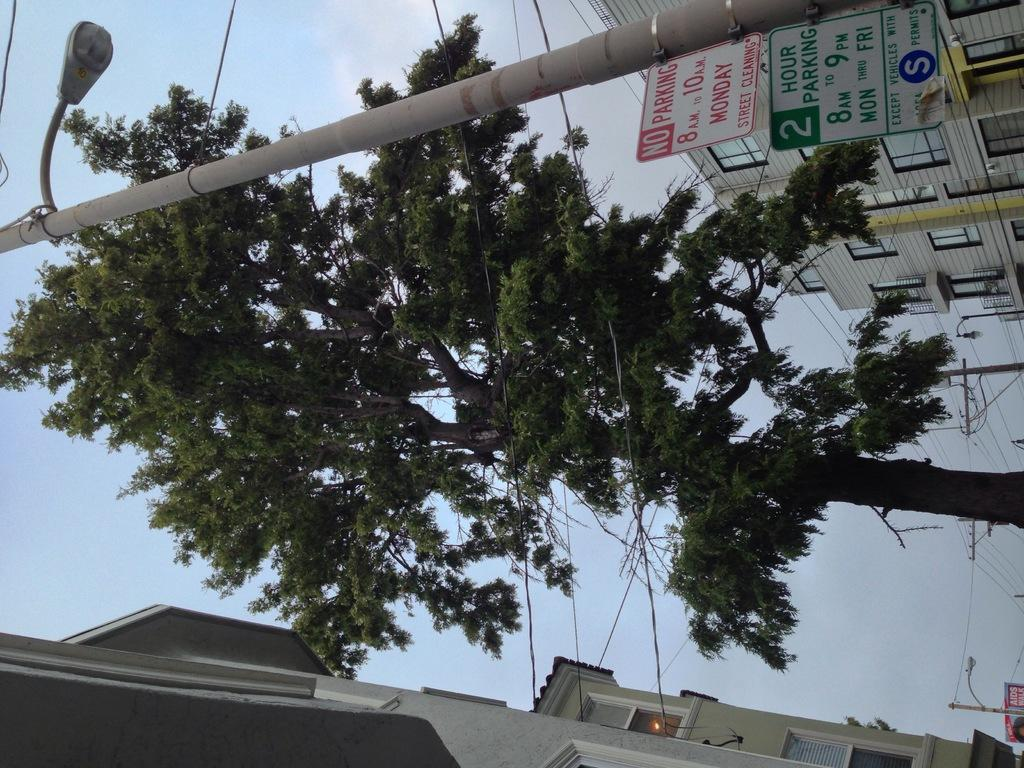What type of structures can be seen in the image? There are buildings in the image. What other objects are present in the image? There are boards and poles in the image. Can you describe the source of light in the image? There is light in the image, but the specific source is not mentioned. What type of vegetation is present in the image? There is a tree in the image. What can be seen in the background of the image? The sky is visible in the background of the image. Can you tell me how many thrills are depicted in the image? There is no mention of thrills in the image; it features buildings, boards, poles, light, a tree, and the sky. Is there a seashore visible in the image? No, there is no seashore present in the image. 